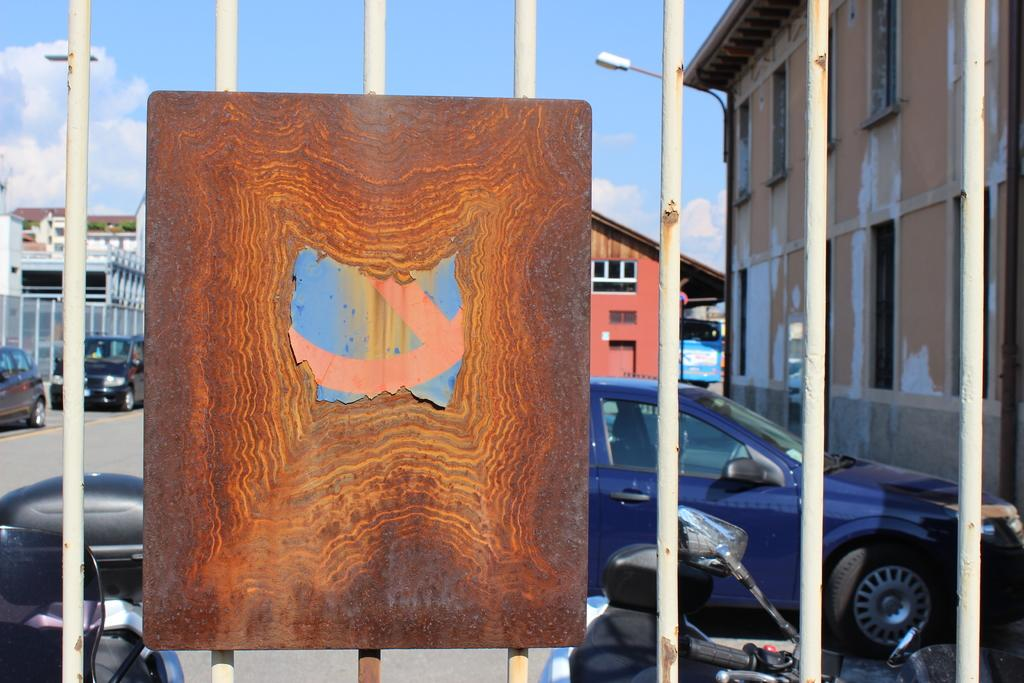What is located in the foreground of the image? There is a gate with a board in the foreground of the image. What can be seen in the background of the image? There are buildings and cars in the background of the image. What is visible at the top of the image? The sky is visible at the top of the image. What type of lighting is present in the image? There are street lights present in the image. What invention is being demonstrated by the cat in the image? There is no cat present in the image, and therefore no invention can be demonstrated by a cat. 